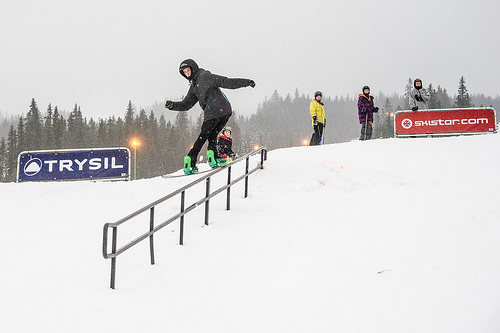What is covered in snow? The hill is blanketed in snow, providing seamless terrain for snowboarding enthusiasts. 